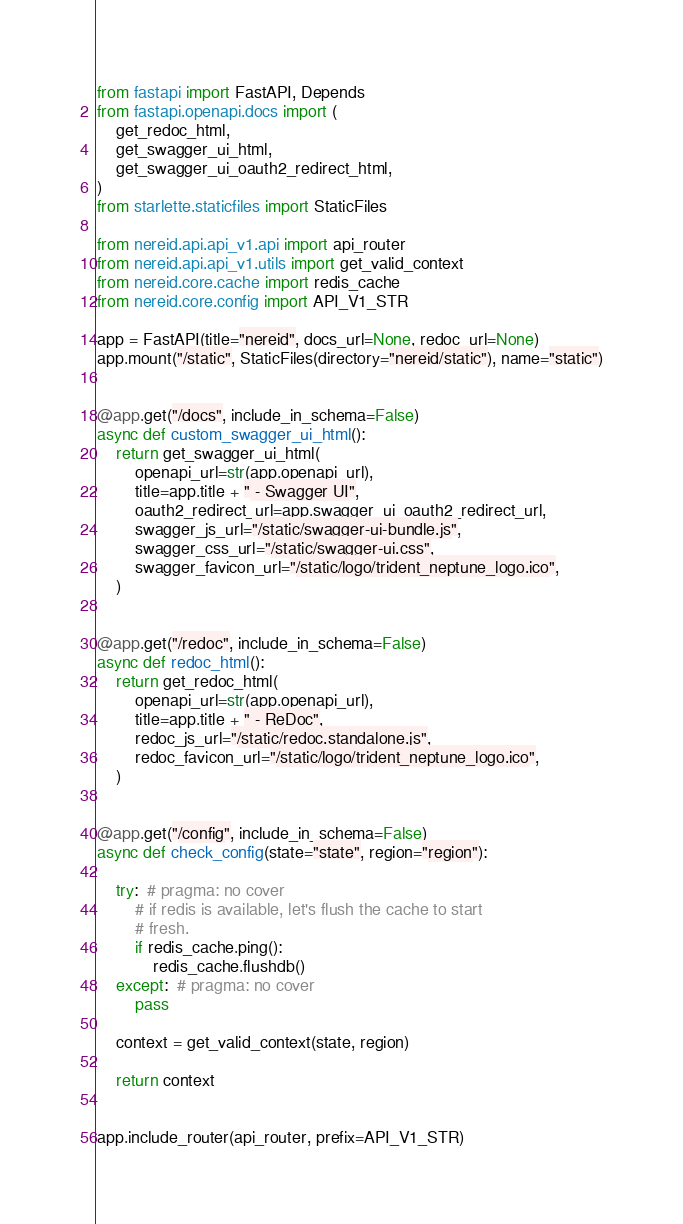Convert code to text. <code><loc_0><loc_0><loc_500><loc_500><_Python_>from fastapi import FastAPI, Depends
from fastapi.openapi.docs import (
    get_redoc_html,
    get_swagger_ui_html,
    get_swagger_ui_oauth2_redirect_html,
)
from starlette.staticfiles import StaticFiles

from nereid.api.api_v1.api import api_router
from nereid.api.api_v1.utils import get_valid_context
from nereid.core.cache import redis_cache
from nereid.core.config import API_V1_STR

app = FastAPI(title="nereid", docs_url=None, redoc_url=None)
app.mount("/static", StaticFiles(directory="nereid/static"), name="static")


@app.get("/docs", include_in_schema=False)
async def custom_swagger_ui_html():
    return get_swagger_ui_html(
        openapi_url=str(app.openapi_url),
        title=app.title + " - Swagger UI",
        oauth2_redirect_url=app.swagger_ui_oauth2_redirect_url,
        swagger_js_url="/static/swagger-ui-bundle.js",
        swagger_css_url="/static/swagger-ui.css",
        swagger_favicon_url="/static/logo/trident_neptune_logo.ico",
    )


@app.get("/redoc", include_in_schema=False)
async def redoc_html():
    return get_redoc_html(
        openapi_url=str(app.openapi_url),
        title=app.title + " - ReDoc",
        redoc_js_url="/static/redoc.standalone.js",
        redoc_favicon_url="/static/logo/trident_neptune_logo.ico",
    )


@app.get("/config", include_in_schema=False)
async def check_config(state="state", region="region"):

    try:  # pragma: no cover
        # if redis is available, let's flush the cache to start
        # fresh.
        if redis_cache.ping():
            redis_cache.flushdb()
    except:  # pragma: no cover
        pass

    context = get_valid_context(state, region)

    return context


app.include_router(api_router, prefix=API_V1_STR)
</code> 